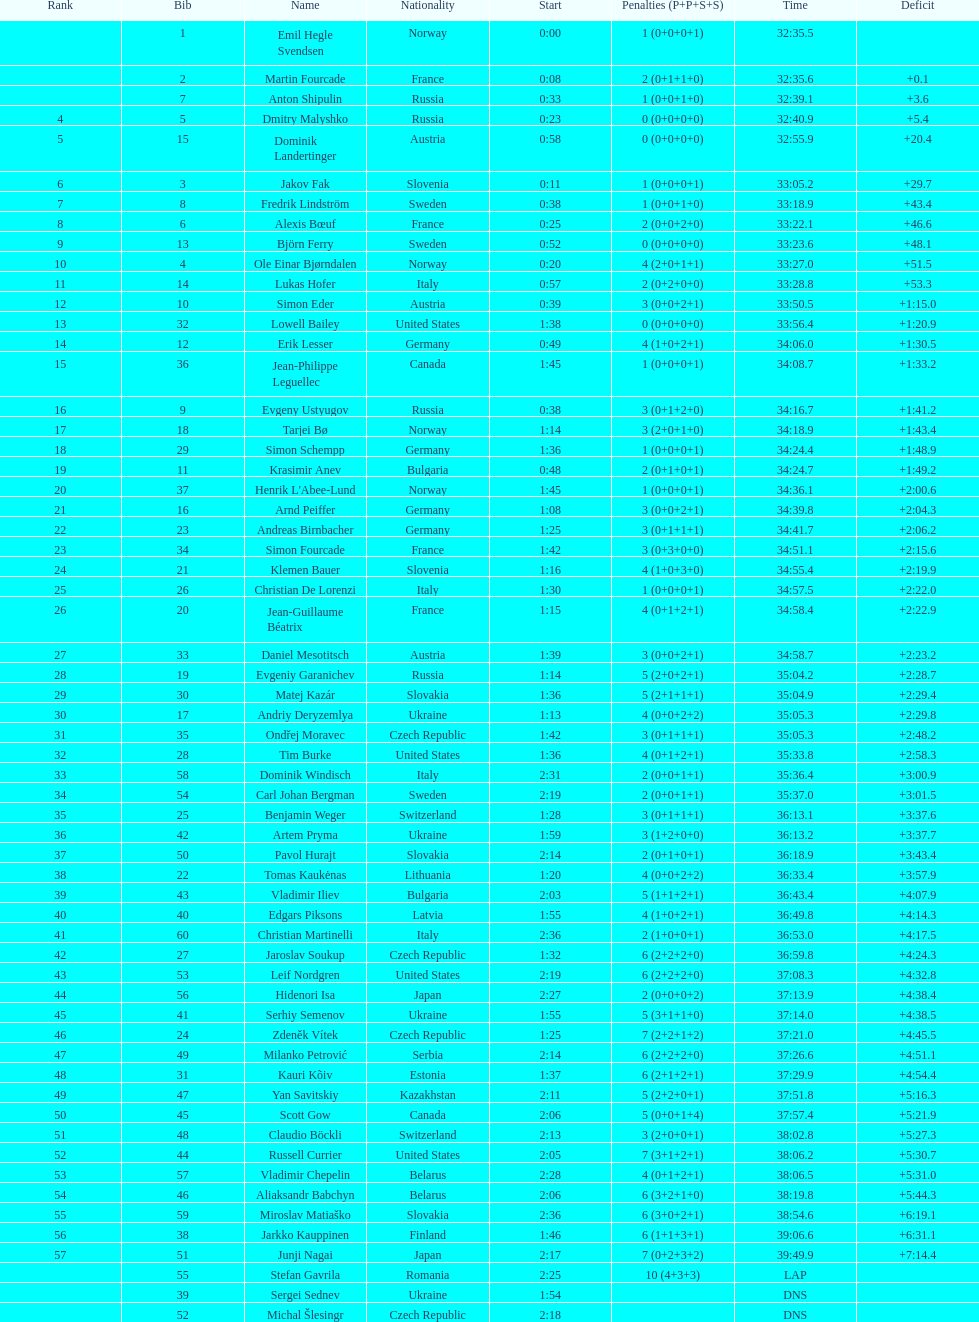How many required 35:00 or more to finish? 30. 